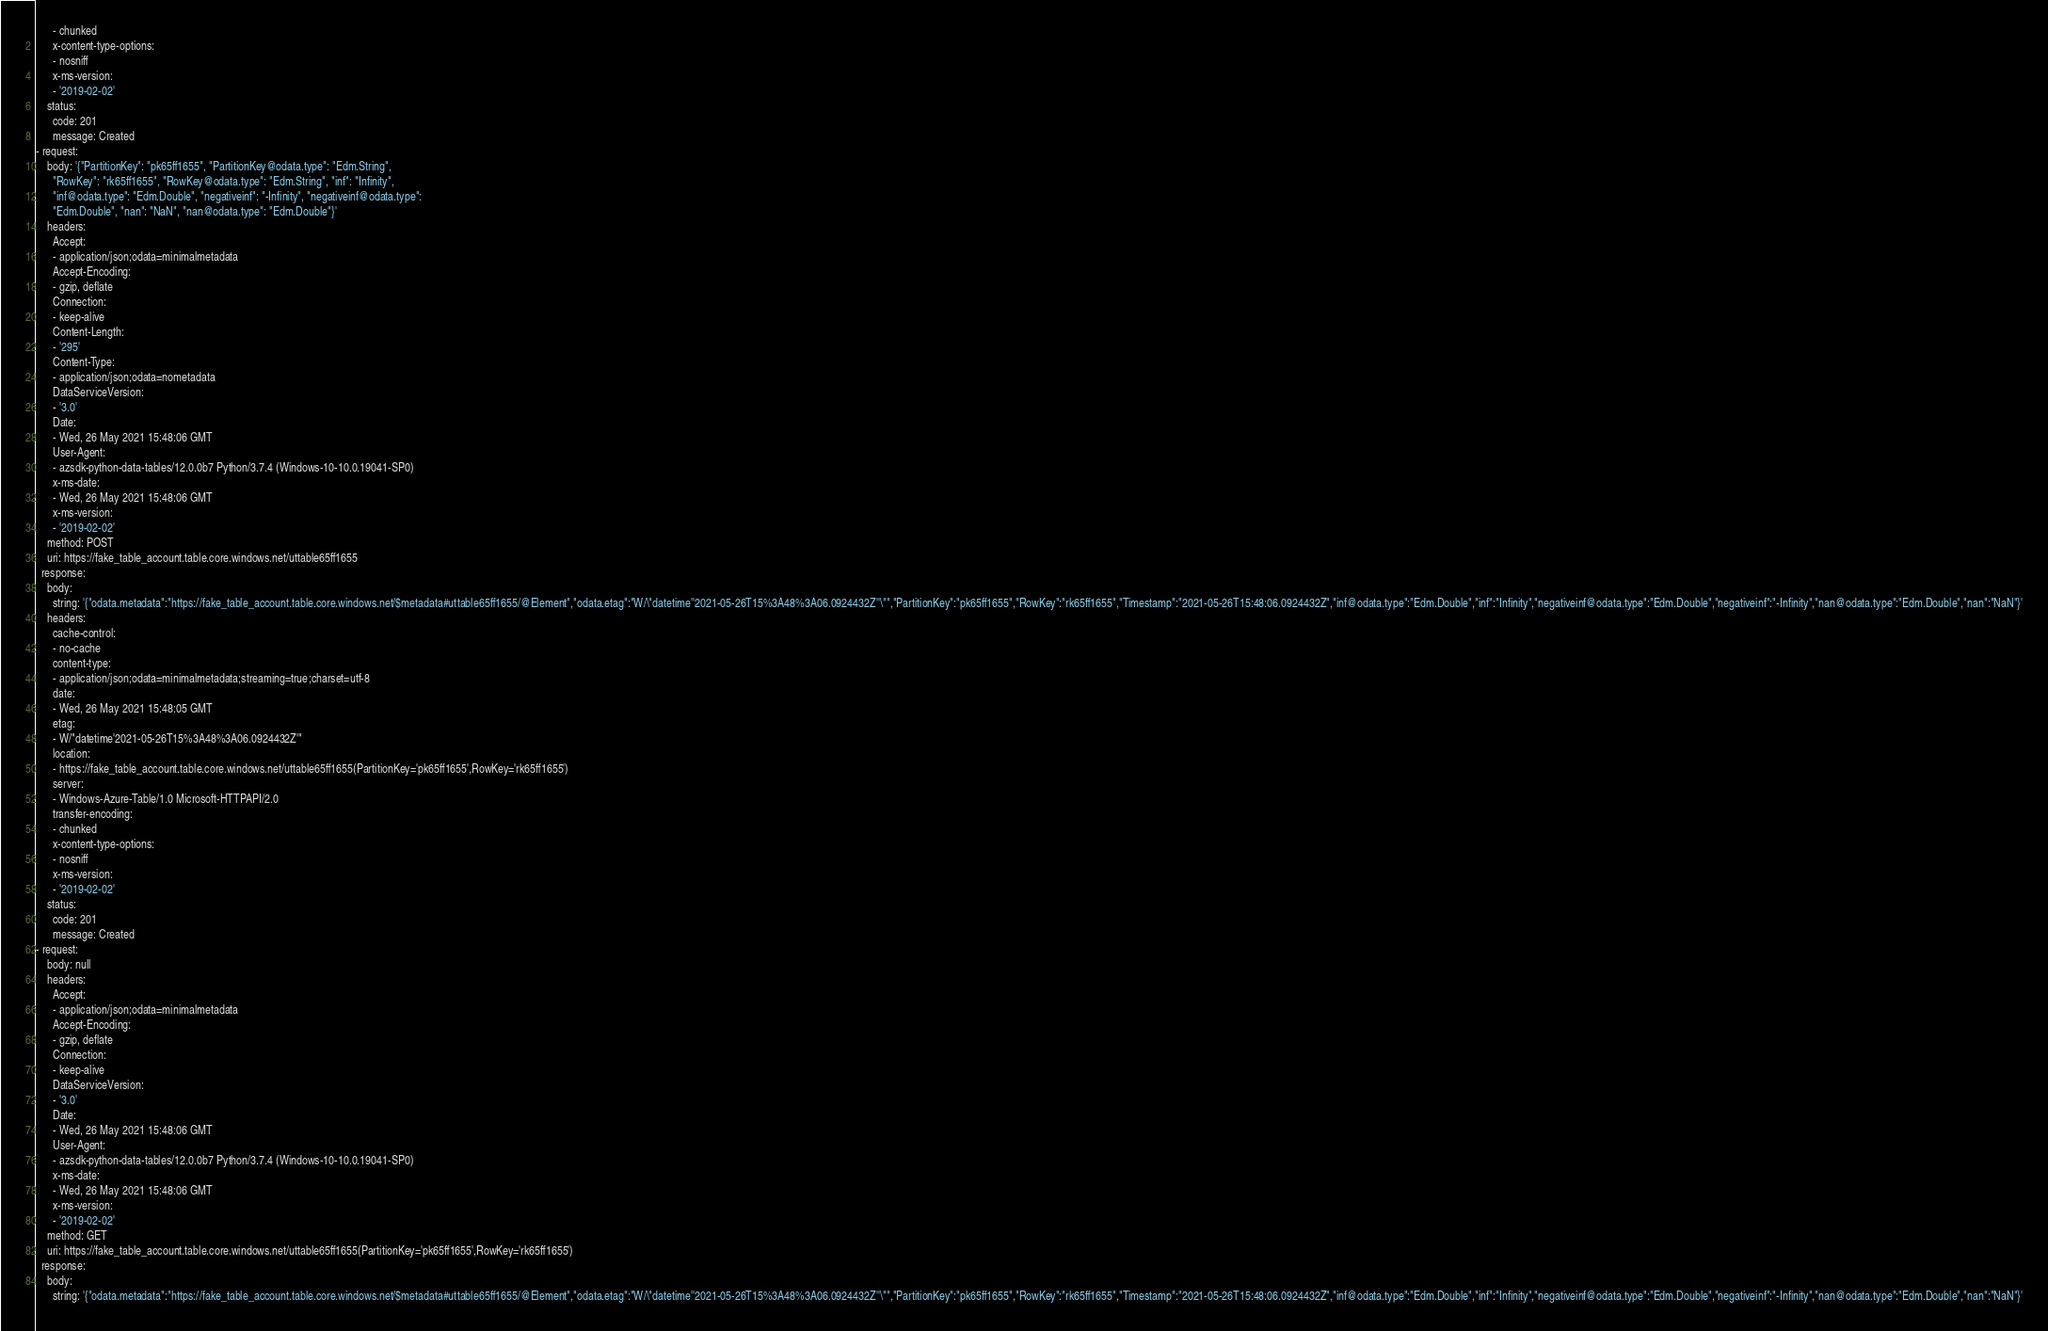<code> <loc_0><loc_0><loc_500><loc_500><_YAML_>      - chunked
      x-content-type-options:
      - nosniff
      x-ms-version:
      - '2019-02-02'
    status:
      code: 201
      message: Created
- request:
    body: '{"PartitionKey": "pk65ff1655", "PartitionKey@odata.type": "Edm.String",
      "RowKey": "rk65ff1655", "RowKey@odata.type": "Edm.String", "inf": "Infinity",
      "inf@odata.type": "Edm.Double", "negativeinf": "-Infinity", "negativeinf@odata.type":
      "Edm.Double", "nan": "NaN", "nan@odata.type": "Edm.Double"}'
    headers:
      Accept:
      - application/json;odata=minimalmetadata
      Accept-Encoding:
      - gzip, deflate
      Connection:
      - keep-alive
      Content-Length:
      - '295'
      Content-Type:
      - application/json;odata=nometadata
      DataServiceVersion:
      - '3.0'
      Date:
      - Wed, 26 May 2021 15:48:06 GMT
      User-Agent:
      - azsdk-python-data-tables/12.0.0b7 Python/3.7.4 (Windows-10-10.0.19041-SP0)
      x-ms-date:
      - Wed, 26 May 2021 15:48:06 GMT
      x-ms-version:
      - '2019-02-02'
    method: POST
    uri: https://fake_table_account.table.core.windows.net/uttable65ff1655
  response:
    body:
      string: '{"odata.metadata":"https://fake_table_account.table.core.windows.net/$metadata#uttable65ff1655/@Element","odata.etag":"W/\"datetime''2021-05-26T15%3A48%3A06.0924432Z''\"","PartitionKey":"pk65ff1655","RowKey":"rk65ff1655","Timestamp":"2021-05-26T15:48:06.0924432Z","inf@odata.type":"Edm.Double","inf":"Infinity","negativeinf@odata.type":"Edm.Double","negativeinf":"-Infinity","nan@odata.type":"Edm.Double","nan":"NaN"}'
    headers:
      cache-control:
      - no-cache
      content-type:
      - application/json;odata=minimalmetadata;streaming=true;charset=utf-8
      date:
      - Wed, 26 May 2021 15:48:05 GMT
      etag:
      - W/"datetime'2021-05-26T15%3A48%3A06.0924432Z'"
      location:
      - https://fake_table_account.table.core.windows.net/uttable65ff1655(PartitionKey='pk65ff1655',RowKey='rk65ff1655')
      server:
      - Windows-Azure-Table/1.0 Microsoft-HTTPAPI/2.0
      transfer-encoding:
      - chunked
      x-content-type-options:
      - nosniff
      x-ms-version:
      - '2019-02-02'
    status:
      code: 201
      message: Created
- request:
    body: null
    headers:
      Accept:
      - application/json;odata=minimalmetadata
      Accept-Encoding:
      - gzip, deflate
      Connection:
      - keep-alive
      DataServiceVersion:
      - '3.0'
      Date:
      - Wed, 26 May 2021 15:48:06 GMT
      User-Agent:
      - azsdk-python-data-tables/12.0.0b7 Python/3.7.4 (Windows-10-10.0.19041-SP0)
      x-ms-date:
      - Wed, 26 May 2021 15:48:06 GMT
      x-ms-version:
      - '2019-02-02'
    method: GET
    uri: https://fake_table_account.table.core.windows.net/uttable65ff1655(PartitionKey='pk65ff1655',RowKey='rk65ff1655')
  response:
    body:
      string: '{"odata.metadata":"https://fake_table_account.table.core.windows.net/$metadata#uttable65ff1655/@Element","odata.etag":"W/\"datetime''2021-05-26T15%3A48%3A06.0924432Z''\"","PartitionKey":"pk65ff1655","RowKey":"rk65ff1655","Timestamp":"2021-05-26T15:48:06.0924432Z","inf@odata.type":"Edm.Double","inf":"Infinity","negativeinf@odata.type":"Edm.Double","negativeinf":"-Infinity","nan@odata.type":"Edm.Double","nan":"NaN"}'</code> 